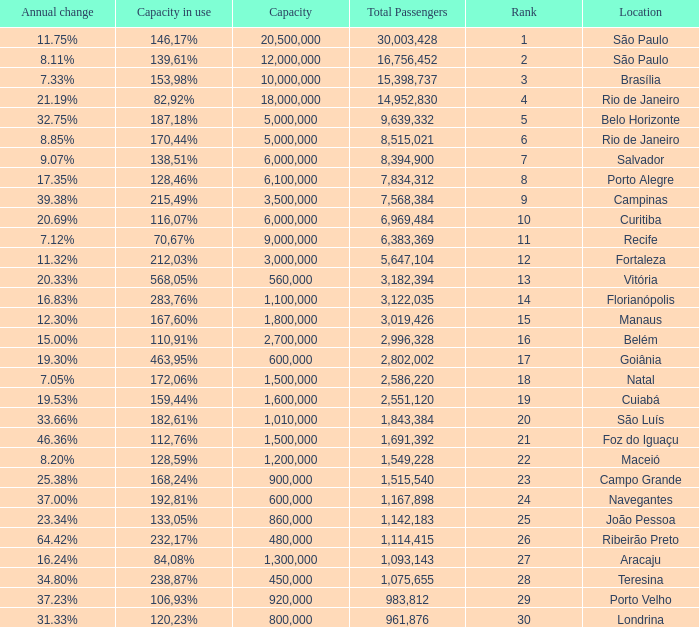What location has an in use capacity of 167,60%? 1800000.0. Help me parse the entirety of this table. {'header': ['Annual change', 'Capacity in use', 'Capacity', 'Total Passengers', 'Rank', 'Location'], 'rows': [['11.75%', '146,17%', '20,500,000', '30,003,428', '1', 'São Paulo'], ['8.11%', '139,61%', '12,000,000', '16,756,452', '2', 'São Paulo'], ['7.33%', '153,98%', '10,000,000', '15,398,737', '3', 'Brasília'], ['21.19%', '82,92%', '18,000,000', '14,952,830', '4', 'Rio de Janeiro'], ['32.75%', '187,18%', '5,000,000', '9,639,332', '5', 'Belo Horizonte'], ['8.85%', '170,44%', '5,000,000', '8,515,021', '6', 'Rio de Janeiro'], ['9.07%', '138,51%', '6,000,000', '8,394,900', '7', 'Salvador'], ['17.35%', '128,46%', '6,100,000', '7,834,312', '8', 'Porto Alegre'], ['39.38%', '215,49%', '3,500,000', '7,568,384', '9', 'Campinas'], ['20.69%', '116,07%', '6,000,000', '6,969,484', '10', 'Curitiba'], ['7.12%', '70,67%', '9,000,000', '6,383,369', '11', 'Recife'], ['11.32%', '212,03%', '3,000,000', '5,647,104', '12', 'Fortaleza'], ['20.33%', '568,05%', '560,000', '3,182,394', '13', 'Vitória'], ['16.83%', '283,76%', '1,100,000', '3,122,035', '14', 'Florianópolis'], ['12.30%', '167,60%', '1,800,000', '3,019,426', '15', 'Manaus'], ['15.00%', '110,91%', '2,700,000', '2,996,328', '16', 'Belém'], ['19.30%', '463,95%', '600,000', '2,802,002', '17', 'Goiânia'], ['7.05%', '172,06%', '1,500,000', '2,586,220', '18', 'Natal'], ['19.53%', '159,44%', '1,600,000', '2,551,120', '19', 'Cuiabá'], ['33.66%', '182,61%', '1,010,000', '1,843,384', '20', 'São Luís'], ['46.36%', '112,76%', '1,500,000', '1,691,392', '21', 'Foz do Iguaçu'], ['8.20%', '128,59%', '1,200,000', '1,549,228', '22', 'Maceió'], ['25.38%', '168,24%', '900,000', '1,515,540', '23', 'Campo Grande'], ['37.00%', '192,81%', '600,000', '1,167,898', '24', 'Navegantes'], ['23.34%', '133,05%', '860,000', '1,142,183', '25', 'João Pessoa'], ['64.42%', '232,17%', '480,000', '1,114,415', '26', 'Ribeirão Preto'], ['16.24%', '84,08%', '1,300,000', '1,093,143', '27', 'Aracaju'], ['34.80%', '238,87%', '450,000', '1,075,655', '28', 'Teresina'], ['37.23%', '106,93%', '920,000', '983,812', '29', 'Porto Velho'], ['31.33%', '120,23%', '800,000', '961,876', '30', 'Londrina']]} 